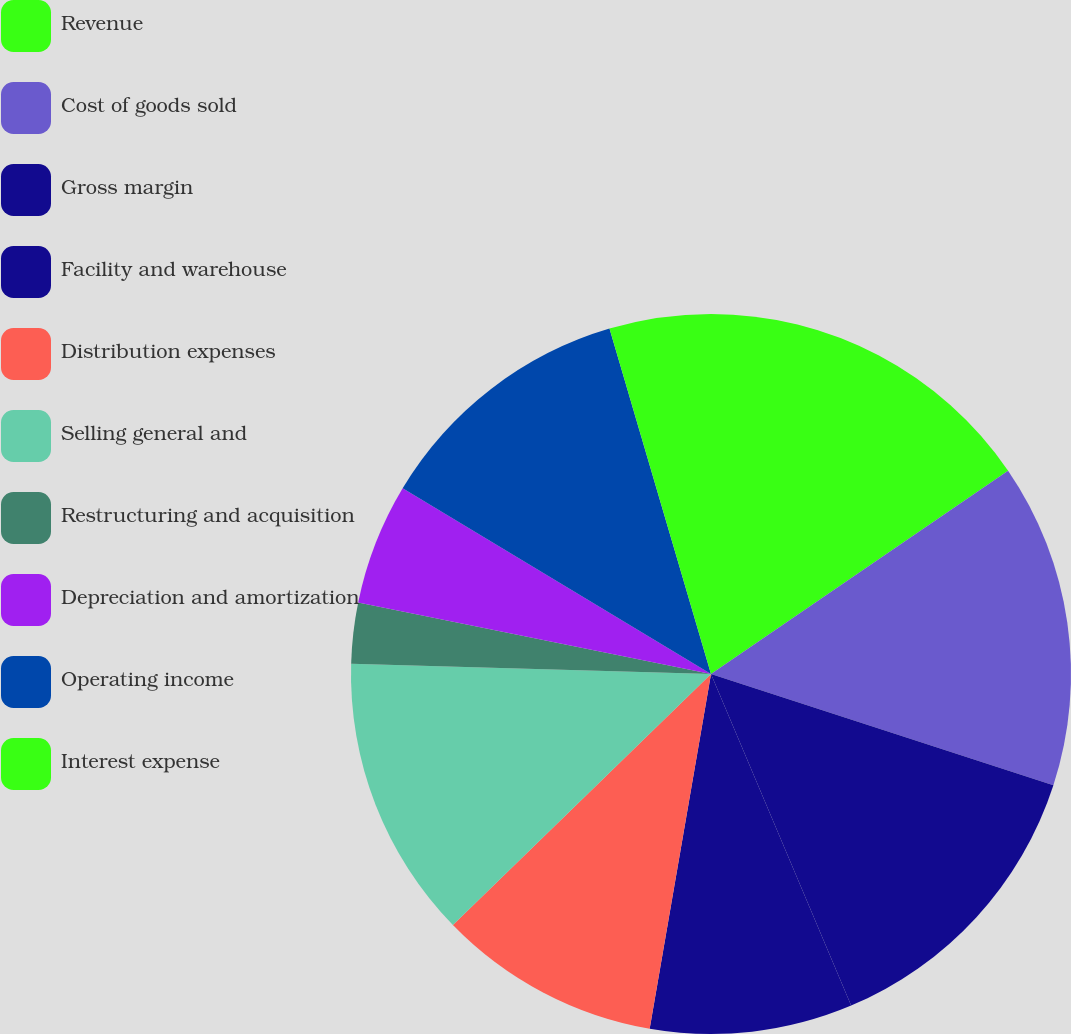<chart> <loc_0><loc_0><loc_500><loc_500><pie_chart><fcel>Revenue<fcel>Cost of goods sold<fcel>Gross margin<fcel>Facility and warehouse<fcel>Distribution expenses<fcel>Selling general and<fcel>Restructuring and acquisition<fcel>Depreciation and amortization<fcel>Operating income<fcel>Interest expense<nl><fcel>15.45%<fcel>14.55%<fcel>13.64%<fcel>9.09%<fcel>10.0%<fcel>12.73%<fcel>2.73%<fcel>5.45%<fcel>11.82%<fcel>4.55%<nl></chart> 